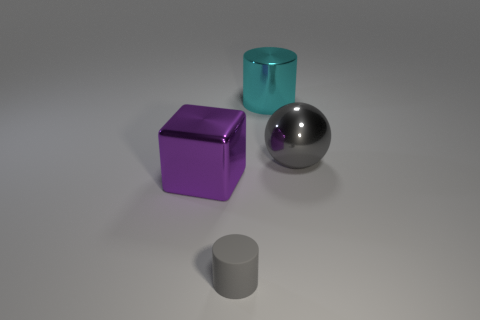What is the size of the object that is both in front of the sphere and right of the block?
Offer a terse response. Small. Are there more big cyan metal cylinders left of the sphere than gray metallic things left of the large shiny cylinder?
Ensure brevity in your answer.  Yes. There is a tiny rubber object that is the same shape as the large cyan object; what is its color?
Offer a very short reply. Gray. There is a cylinder to the left of the big cyan metal cylinder; does it have the same color as the large cylinder?
Your response must be concise. No. What number of metallic blocks are there?
Your response must be concise. 1. Are the large object that is on the left side of the gray matte object and the gray ball made of the same material?
Offer a very short reply. Yes. Is there anything else that has the same material as the small gray cylinder?
Your response must be concise. No. There is a cylinder left of the big object that is behind the big gray ball; what number of things are behind it?
Provide a short and direct response. 3. What is the size of the purple metallic cube?
Your answer should be very brief. Large. Is the big shiny ball the same color as the small thing?
Your response must be concise. Yes. 